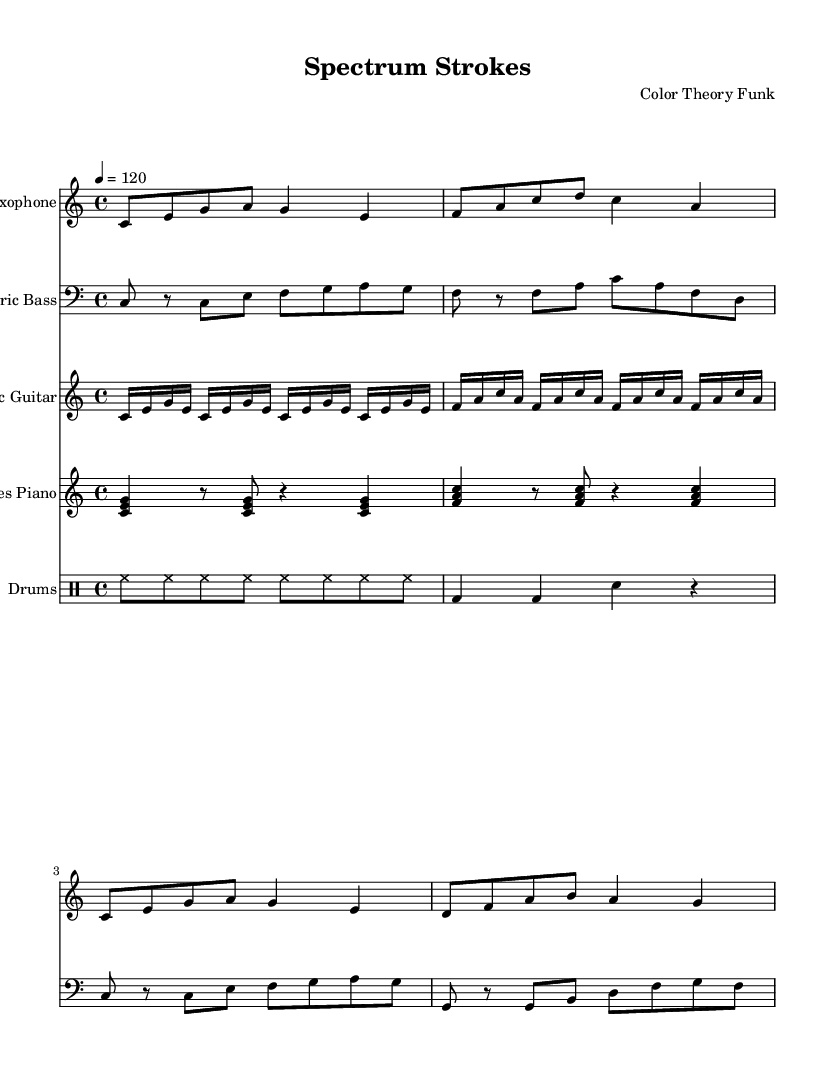What is the key signature of this music? The key signature is C major, which has no sharps or flats indicated in the sheet music.
Answer: C major What is the time signature of this music? The time signature is 4/4, as shown at the beginning of the score.
Answer: 4/4 What is the tempo marking of this piece? The tempo marking indicates 120 beats per minute, specifically noted as "4 = 120" in the score.
Answer: 120 How many measures are in the saxophone melody? The saxophone part has four measures, explicitly indicated by the grouping of notes and bar lines.
Answer: 4 Which instruments are featured in this piece? The instruments listed in the score are Saxophone, Electric Bass, Electric Guitar, Rhodes Piano, and Drums, as seen in the respective staff names.
Answer: Saxophone, Electric Bass, Electric Guitar, Rhodes Piano, Drums What kind of rhythmic pattern is primarily used in the drum section? The drum section exhibits a consistent hi-hat pattern with kick drum accents, creating a funk groove typical of the genre.
Answer: Funk groove What is the style of this composition? This composition is categorized as funk, characterized by its rhythmic patterns and instrumental layers that embody funk elements inspired by color theory and artistic techniques.
Answer: Funk 